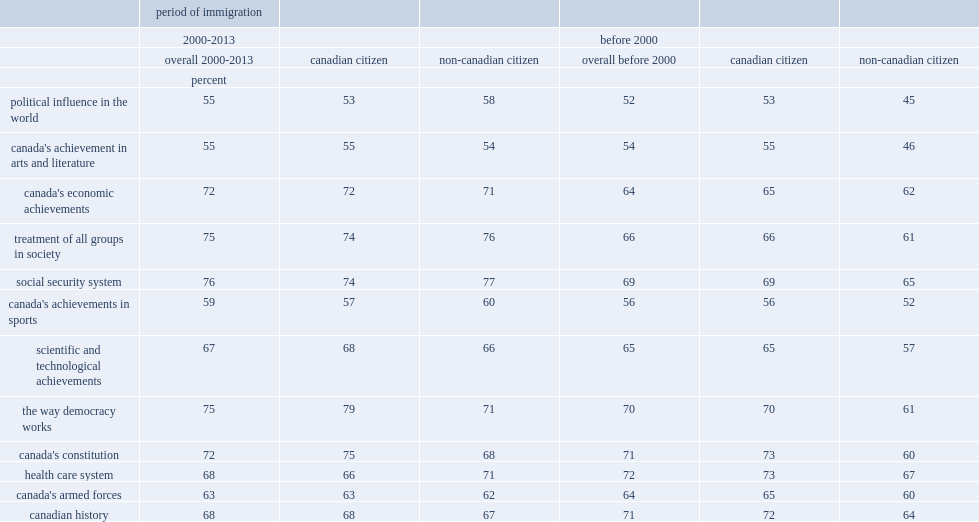What percent of recent immigrants was proud of canada's economic achievements? 72. What percent of non-citizens has pride in canadian democracy? 71. Which group of immigrants was less likely to positively view canada's health care system? immigrants with canadian citizen or non-citizens? Canadian citizen. What percent of pride in the canadian constitution was higher among citizens than non-citizens before 2000? 13. What percent of canadian citizen is proud or very proud in sporting achievements recently? 57. 